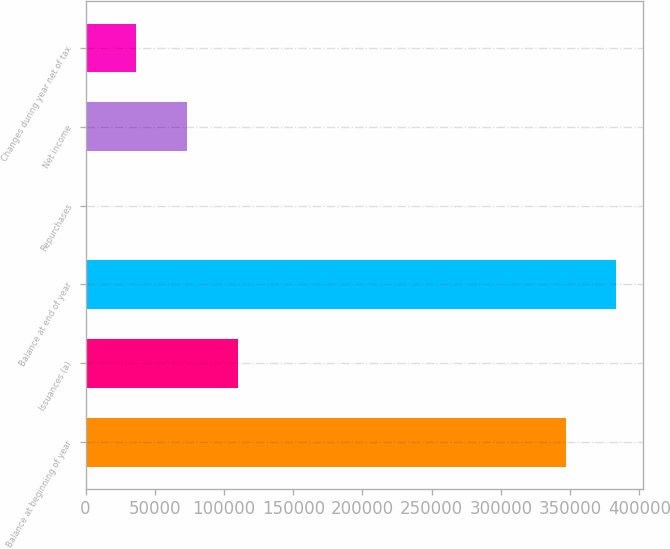<chart> <loc_0><loc_0><loc_500><loc_500><bar_chart><fcel>Balance at beginning of year<fcel>Issuances (a)<fcel>Balance at end of year<fcel>Repurchases<fcel>Net income<fcel>Changes during year net of tax<nl><fcel>346718<fcel>110085<fcel>383410<fcel>10<fcel>73393.2<fcel>36701.6<nl></chart> 